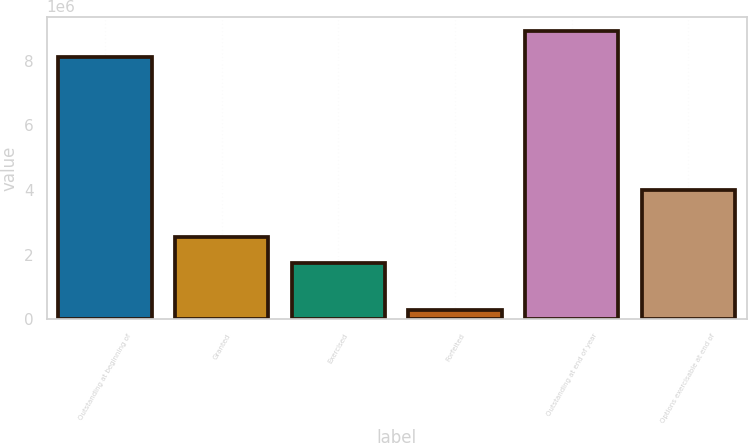Convert chart to OTSL. <chart><loc_0><loc_0><loc_500><loc_500><bar_chart><fcel>Outstanding at beginning of<fcel>Granted<fcel>Exercised<fcel>Forfeited<fcel>Outstanding at end of year<fcel>Options exercisable at end of<nl><fcel>8.10289e+06<fcel>2.55771e+06<fcel>1.74733e+06<fcel>302729<fcel>8.91327e+06<fcel>4.00116e+06<nl></chart> 